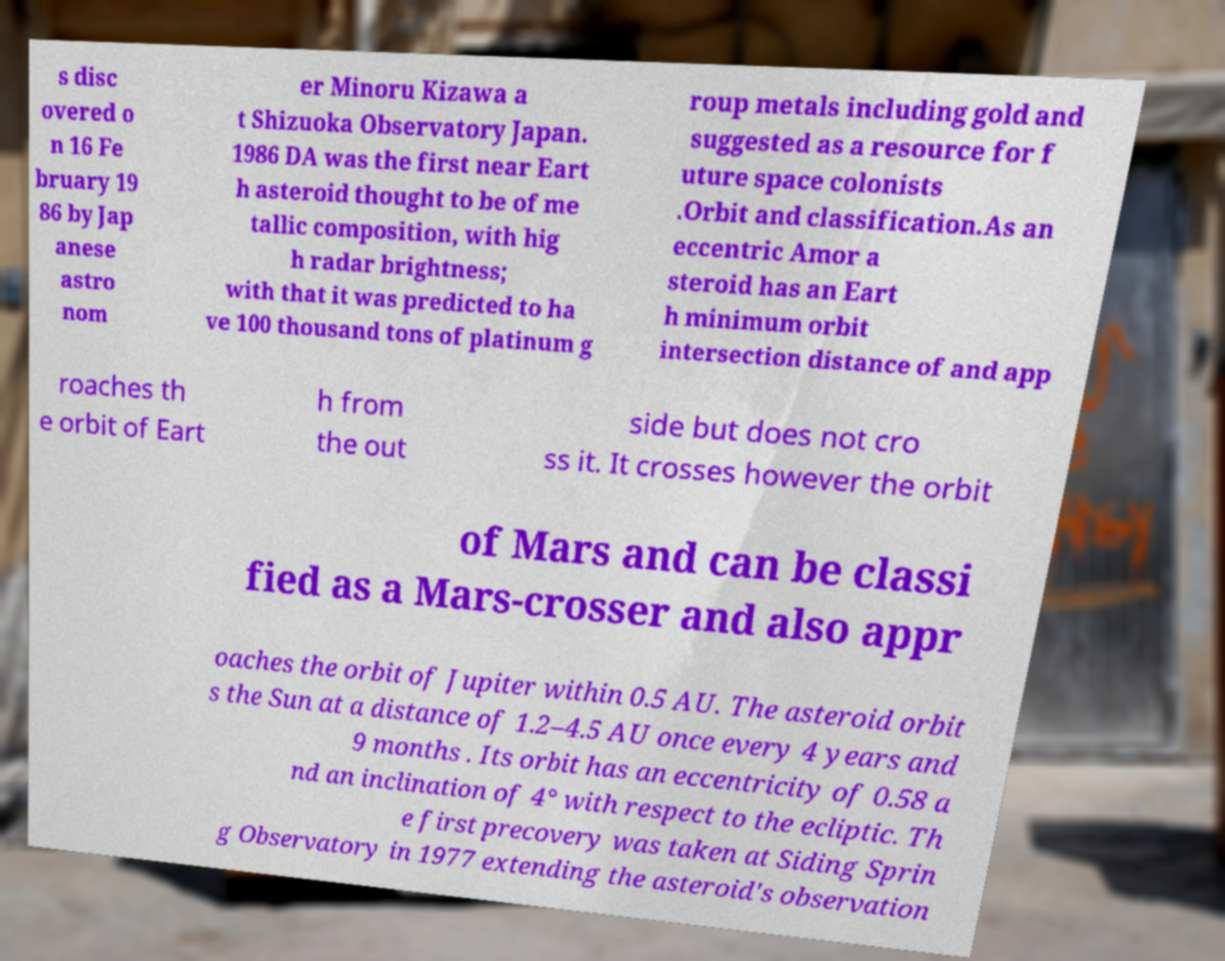Could you extract and type out the text from this image? s disc overed o n 16 Fe bruary 19 86 by Jap anese astro nom er Minoru Kizawa a t Shizuoka Observatory Japan. 1986 DA was the first near Eart h asteroid thought to be of me tallic composition, with hig h radar brightness; with that it was predicted to ha ve 100 thousand tons of platinum g roup metals including gold and suggested as a resource for f uture space colonists .Orbit and classification.As an eccentric Amor a steroid has an Eart h minimum orbit intersection distance of and app roaches th e orbit of Eart h from the out side but does not cro ss it. It crosses however the orbit of Mars and can be classi fied as a Mars-crosser and also appr oaches the orbit of Jupiter within 0.5 AU. The asteroid orbit s the Sun at a distance of 1.2–4.5 AU once every 4 years and 9 months . Its orbit has an eccentricity of 0.58 a nd an inclination of 4° with respect to the ecliptic. Th e first precovery was taken at Siding Sprin g Observatory in 1977 extending the asteroid's observation 